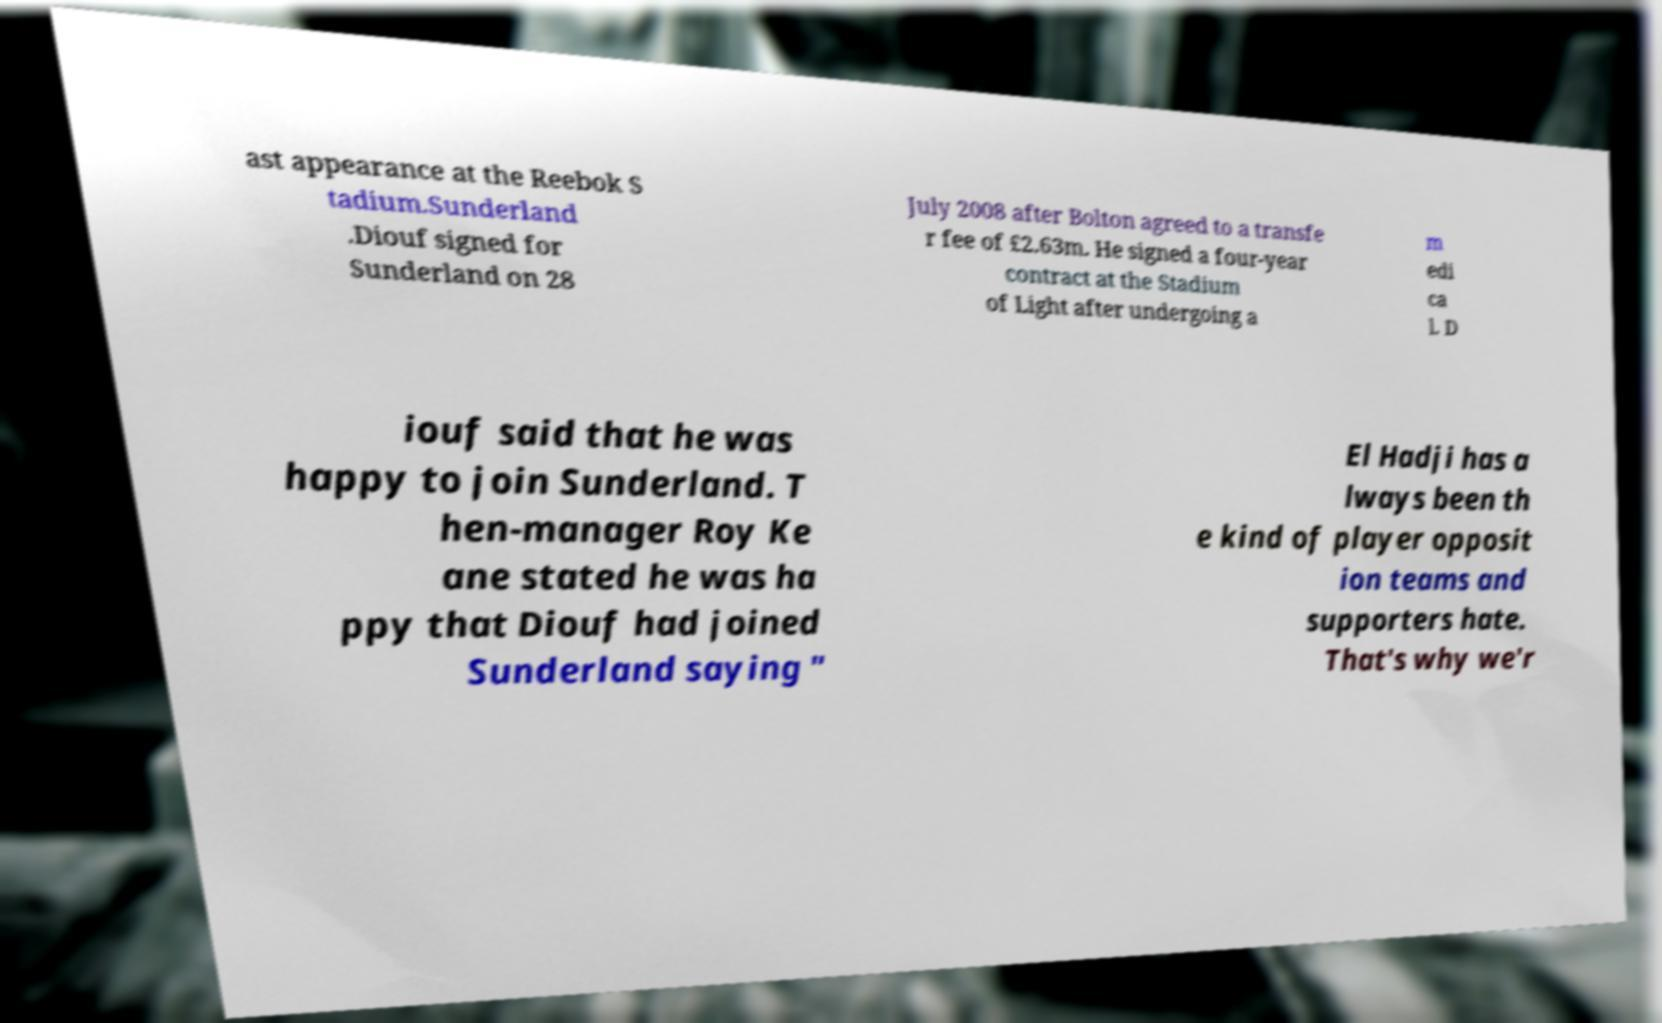For documentation purposes, I need the text within this image transcribed. Could you provide that? ast appearance at the Reebok S tadium.Sunderland .Diouf signed for Sunderland on 28 July 2008 after Bolton agreed to a transfe r fee of £2.63m. He signed a four-year contract at the Stadium of Light after undergoing a m edi ca l. D iouf said that he was happy to join Sunderland. T hen-manager Roy Ke ane stated he was ha ppy that Diouf had joined Sunderland saying " El Hadji has a lways been th e kind of player opposit ion teams and supporters hate. That's why we'r 